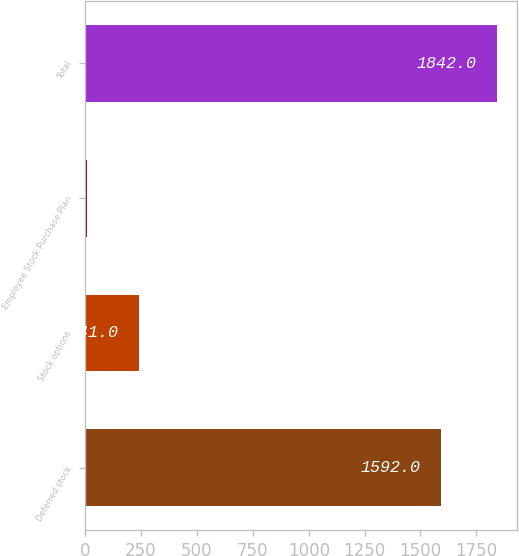Convert chart to OTSL. <chart><loc_0><loc_0><loc_500><loc_500><bar_chart><fcel>Deferred stock<fcel>Stock options<fcel>Employee Stock Purchase Plan<fcel>Total<nl><fcel>1592<fcel>241<fcel>9<fcel>1842<nl></chart> 